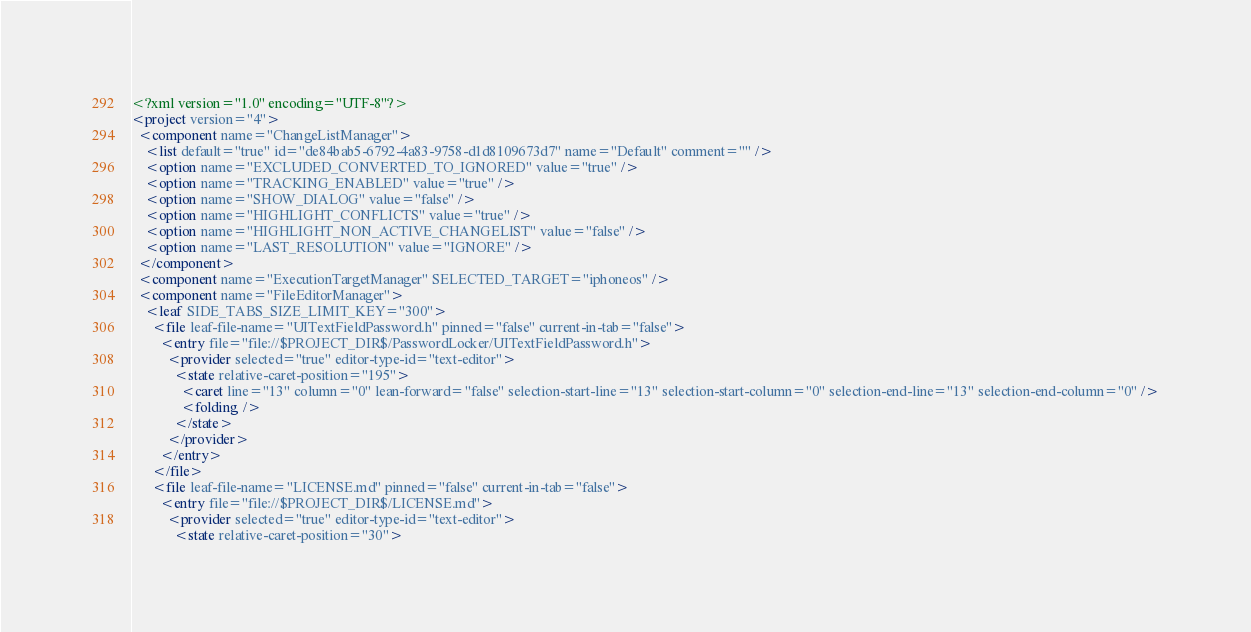Convert code to text. <code><loc_0><loc_0><loc_500><loc_500><_XML_><?xml version="1.0" encoding="UTF-8"?>
<project version="4">
  <component name="ChangeListManager">
    <list default="true" id="de84bab5-6792-4a83-9758-d1d8109673d7" name="Default" comment="" />
    <option name="EXCLUDED_CONVERTED_TO_IGNORED" value="true" />
    <option name="TRACKING_ENABLED" value="true" />
    <option name="SHOW_DIALOG" value="false" />
    <option name="HIGHLIGHT_CONFLICTS" value="true" />
    <option name="HIGHLIGHT_NON_ACTIVE_CHANGELIST" value="false" />
    <option name="LAST_RESOLUTION" value="IGNORE" />
  </component>
  <component name="ExecutionTargetManager" SELECTED_TARGET="iphoneos" />
  <component name="FileEditorManager">
    <leaf SIDE_TABS_SIZE_LIMIT_KEY="300">
      <file leaf-file-name="UITextFieldPassword.h" pinned="false" current-in-tab="false">
        <entry file="file://$PROJECT_DIR$/PasswordLocker/UITextFieldPassword.h">
          <provider selected="true" editor-type-id="text-editor">
            <state relative-caret-position="195">
              <caret line="13" column="0" lean-forward="false" selection-start-line="13" selection-start-column="0" selection-end-line="13" selection-end-column="0" />
              <folding />
            </state>
          </provider>
        </entry>
      </file>
      <file leaf-file-name="LICENSE.md" pinned="false" current-in-tab="false">
        <entry file="file://$PROJECT_DIR$/LICENSE.md">
          <provider selected="true" editor-type-id="text-editor">
            <state relative-caret-position="30"></code> 